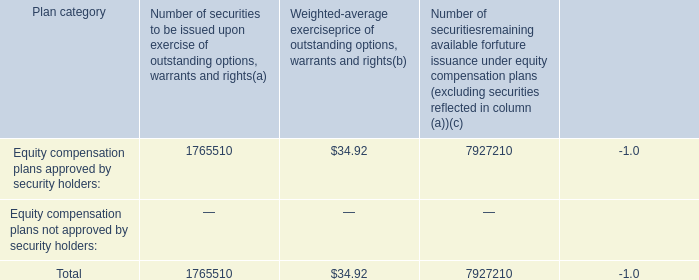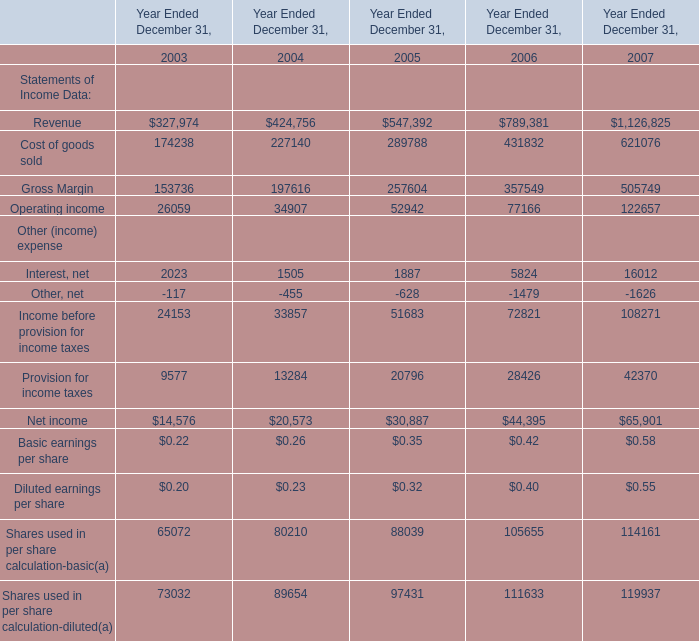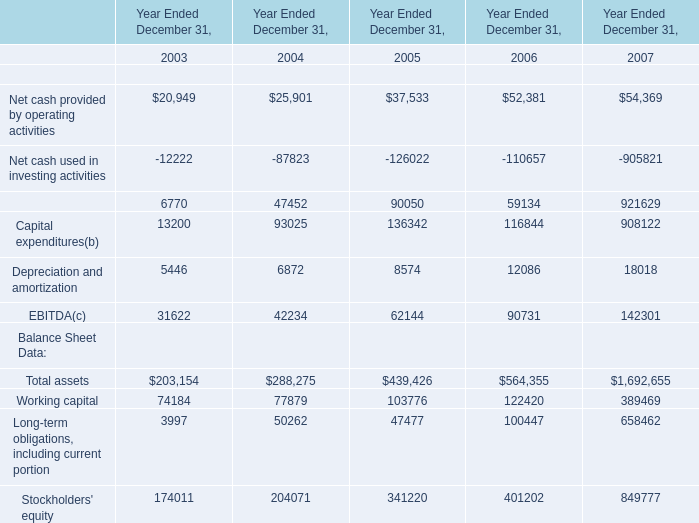In what year is Net cash provided by financing activities greater than 50000? 
Answer: 2005 2006 2007. 